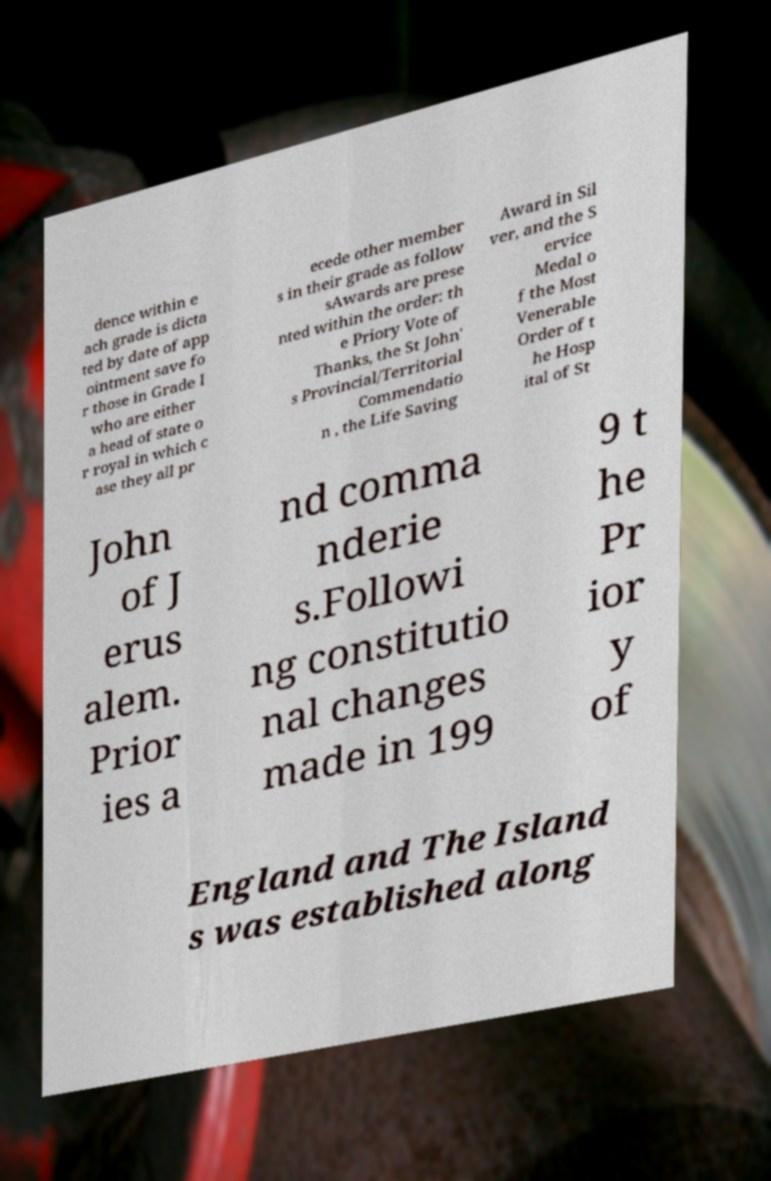I need the written content from this picture converted into text. Can you do that? dence within e ach grade is dicta ted by date of app ointment save fo r those in Grade I who are either a head of state o r royal in which c ase they all pr ecede other member s in their grade as follow sAwards are prese nted within the order: th e Priory Vote of Thanks, the St John' s Provincial/Territorial Commendatio n , the Life Saving Award in Sil ver, and the S ervice Medal o f the Most Venerable Order of t he Hosp ital of St John of J erus alem. Prior ies a nd comma nderie s.Followi ng constitutio nal changes made in 199 9 t he Pr ior y of England and The Island s was established along 